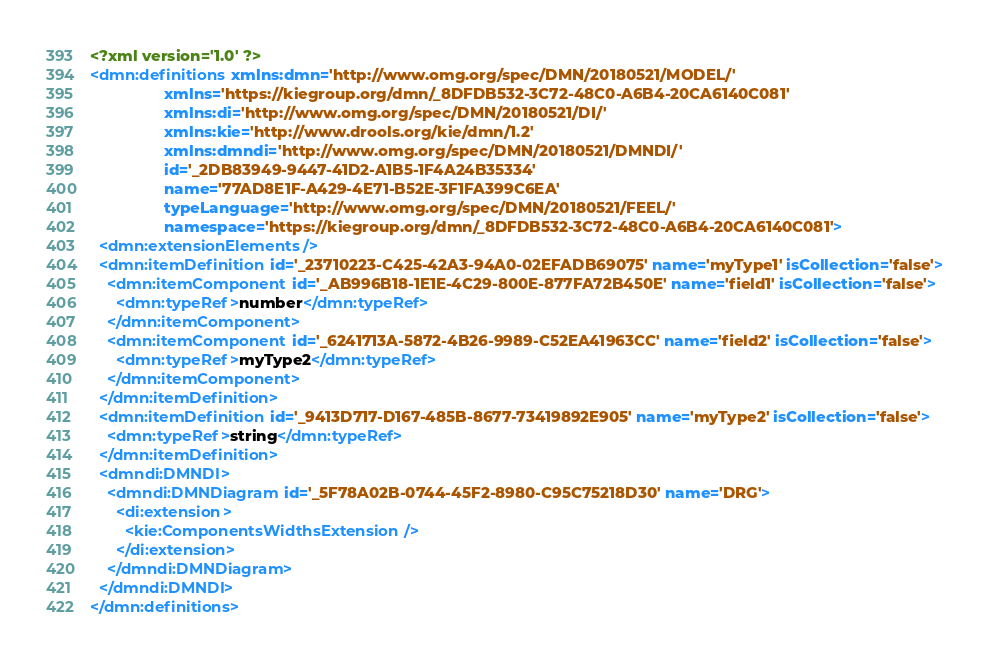<code> <loc_0><loc_0><loc_500><loc_500><_XML_><?xml version='1.0' ?>
<dmn:definitions xmlns:dmn='http://www.omg.org/spec/DMN/20180521/MODEL/'
                 xmlns='https://kiegroup.org/dmn/_8DFDB532-3C72-48C0-A6B4-20CA6140C081'
                 xmlns:di='http://www.omg.org/spec/DMN/20180521/DI/'
                 xmlns:kie='http://www.drools.org/kie/dmn/1.2'
                 xmlns:dmndi='http://www.omg.org/spec/DMN/20180521/DMNDI/'
                 id='_2DB83949-9447-41D2-A1B5-1F4A24B35334'
                 name='77AD8E1F-A429-4E71-B52E-3F1FA399C6EA'
                 typeLanguage='http://www.omg.org/spec/DMN/20180521/FEEL/'
                 namespace='https://kiegroup.org/dmn/_8DFDB532-3C72-48C0-A6B4-20CA6140C081'>
  <dmn:extensionElements/>
  <dmn:itemDefinition id='_23710223-C425-42A3-94A0-02EFADB69075' name='myType1' isCollection='false'>
    <dmn:itemComponent id='_AB996B18-1E1E-4C29-800E-877FA72B450E' name='field1' isCollection='false'>
      <dmn:typeRef>number</dmn:typeRef>
    </dmn:itemComponent>
    <dmn:itemComponent id='_6241713A-5872-4B26-9989-C52EA41963CC' name='field2' isCollection='false'>
      <dmn:typeRef>myType2</dmn:typeRef>
    </dmn:itemComponent>
  </dmn:itemDefinition>
  <dmn:itemDefinition id='_9413D717-D167-485B-8677-73419892E905' name='myType2' isCollection='false'>
    <dmn:typeRef>string</dmn:typeRef>
  </dmn:itemDefinition>
  <dmndi:DMNDI>
    <dmndi:DMNDiagram id='_5F78A02B-0744-45F2-8980-C95C75218D30' name='DRG'>
      <di:extension>
        <kie:ComponentsWidthsExtension/>
      </di:extension>
    </dmndi:DMNDiagram>
  </dmndi:DMNDI>
</dmn:definitions></code> 